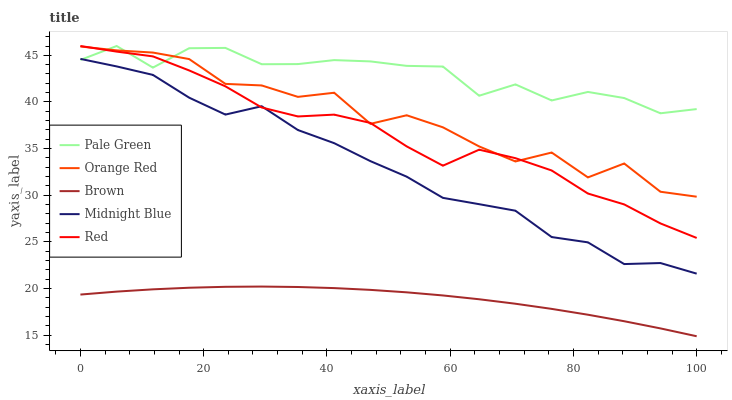Does Brown have the minimum area under the curve?
Answer yes or no. Yes. Does Pale Green have the maximum area under the curve?
Answer yes or no. Yes. Does Orange Red have the minimum area under the curve?
Answer yes or no. No. Does Orange Red have the maximum area under the curve?
Answer yes or no. No. Is Brown the smoothest?
Answer yes or no. Yes. Is Orange Red the roughest?
Answer yes or no. Yes. Is Pale Green the smoothest?
Answer yes or no. No. Is Pale Green the roughest?
Answer yes or no. No. Does Brown have the lowest value?
Answer yes or no. Yes. Does Orange Red have the lowest value?
Answer yes or no. No. Does Red have the highest value?
Answer yes or no. Yes. Does Orange Red have the highest value?
Answer yes or no. No. Is Brown less than Pale Green?
Answer yes or no. Yes. Is Orange Red greater than Brown?
Answer yes or no. Yes. Does Orange Red intersect Pale Green?
Answer yes or no. Yes. Is Orange Red less than Pale Green?
Answer yes or no. No. Is Orange Red greater than Pale Green?
Answer yes or no. No. Does Brown intersect Pale Green?
Answer yes or no. No. 